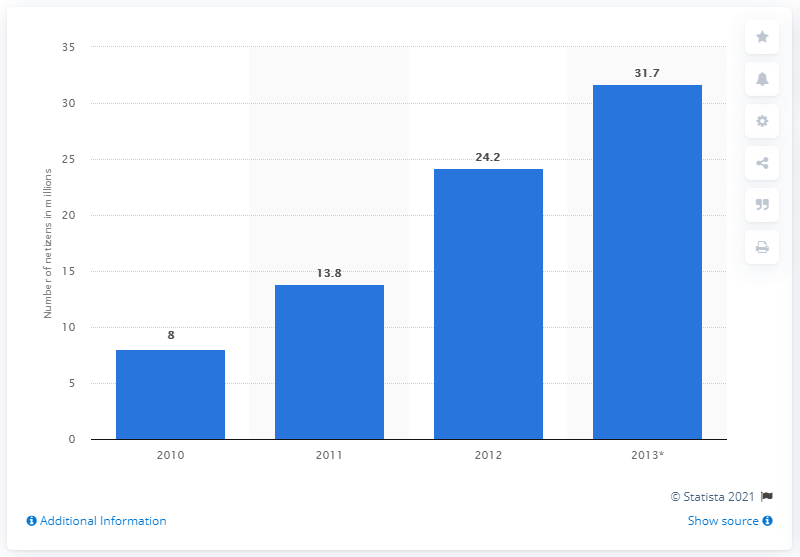List a handful of essential elements in this visual. In the year 2010, the number of netizens in Indonesia began to increase significantly. In 2013, around 31.7% of Indonesian netizens spent at least 3 hours per day online. There were approximately 24.2 million netizens in Indonesia in 2012. 